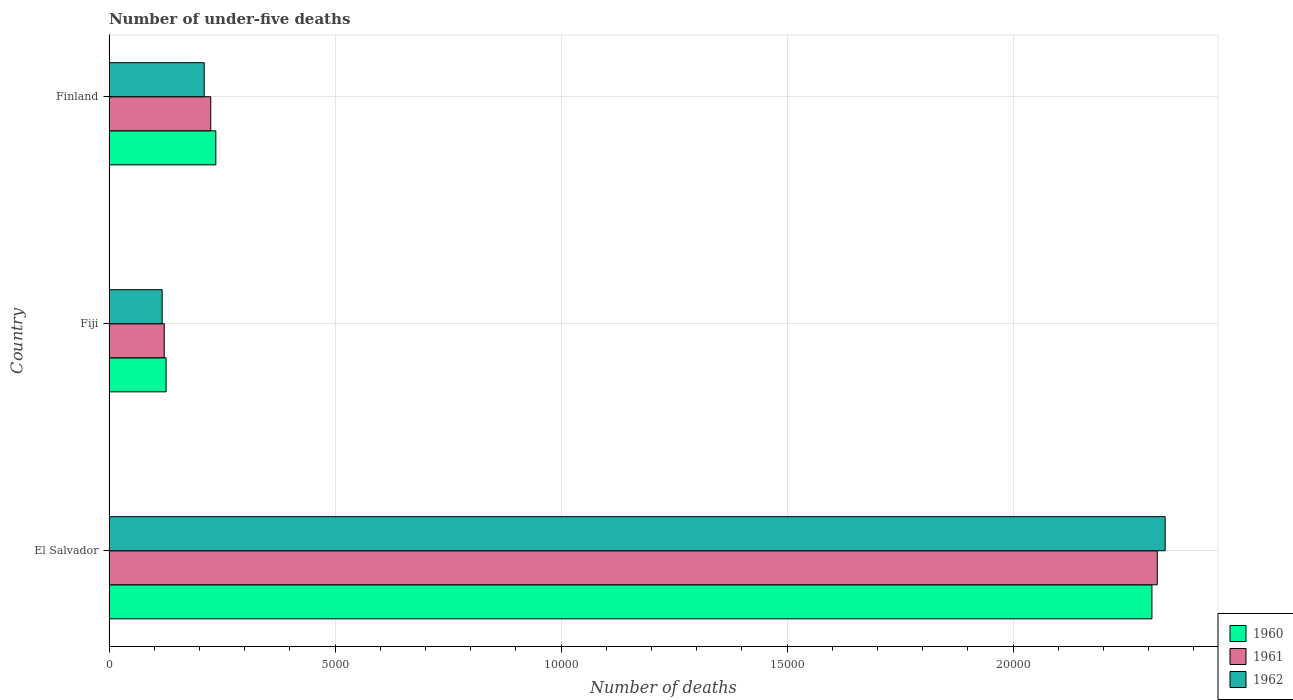How many groups of bars are there?
Provide a succinct answer. 3. Are the number of bars per tick equal to the number of legend labels?
Give a very brief answer. Yes. What is the label of the 2nd group of bars from the top?
Your answer should be very brief. Fiji. In how many cases, is the number of bars for a given country not equal to the number of legend labels?
Give a very brief answer. 0. What is the number of under-five deaths in 1961 in Fiji?
Offer a very short reply. 1222. Across all countries, what is the maximum number of under-five deaths in 1961?
Ensure brevity in your answer.  2.32e+04. Across all countries, what is the minimum number of under-five deaths in 1960?
Your answer should be very brief. 1263. In which country was the number of under-five deaths in 1962 maximum?
Keep it short and to the point. El Salvador. In which country was the number of under-five deaths in 1961 minimum?
Your response must be concise. Fiji. What is the total number of under-five deaths in 1960 in the graph?
Make the answer very short. 2.67e+04. What is the difference between the number of under-five deaths in 1962 in Fiji and that in Finland?
Provide a succinct answer. -930. What is the difference between the number of under-five deaths in 1960 in El Salvador and the number of under-five deaths in 1962 in Finland?
Provide a short and direct response. 2.10e+04. What is the average number of under-five deaths in 1961 per country?
Provide a succinct answer. 8888. What is the ratio of the number of under-five deaths in 1962 in El Salvador to that in Fiji?
Offer a terse response. 19.87. Is the difference between the number of under-five deaths in 1960 in El Salvador and Finland greater than the difference between the number of under-five deaths in 1961 in El Salvador and Finland?
Offer a very short reply. No. What is the difference between the highest and the second highest number of under-five deaths in 1962?
Give a very brief answer. 2.13e+04. What is the difference between the highest and the lowest number of under-five deaths in 1960?
Provide a succinct answer. 2.18e+04. Is the sum of the number of under-five deaths in 1962 in Fiji and Finland greater than the maximum number of under-five deaths in 1960 across all countries?
Offer a very short reply. No. How many bars are there?
Your answer should be compact. 9. Are all the bars in the graph horizontal?
Your answer should be compact. Yes. Does the graph contain any zero values?
Your response must be concise. No. Does the graph contain grids?
Offer a very short reply. Yes. Where does the legend appear in the graph?
Your response must be concise. Bottom right. How many legend labels are there?
Ensure brevity in your answer.  3. What is the title of the graph?
Your answer should be very brief. Number of under-five deaths. What is the label or title of the X-axis?
Provide a succinct answer. Number of deaths. What is the Number of deaths in 1960 in El Salvador?
Make the answer very short. 2.31e+04. What is the Number of deaths in 1961 in El Salvador?
Provide a short and direct response. 2.32e+04. What is the Number of deaths in 1962 in El Salvador?
Offer a terse response. 2.34e+04. What is the Number of deaths in 1960 in Fiji?
Offer a terse response. 1263. What is the Number of deaths in 1961 in Fiji?
Provide a short and direct response. 1222. What is the Number of deaths of 1962 in Fiji?
Keep it short and to the point. 1176. What is the Number of deaths in 1960 in Finland?
Keep it short and to the point. 2363. What is the Number of deaths of 1961 in Finland?
Your response must be concise. 2251. What is the Number of deaths of 1962 in Finland?
Your answer should be very brief. 2106. Across all countries, what is the maximum Number of deaths of 1960?
Provide a short and direct response. 2.31e+04. Across all countries, what is the maximum Number of deaths of 1961?
Ensure brevity in your answer.  2.32e+04. Across all countries, what is the maximum Number of deaths in 1962?
Your answer should be compact. 2.34e+04. Across all countries, what is the minimum Number of deaths of 1960?
Offer a very short reply. 1263. Across all countries, what is the minimum Number of deaths in 1961?
Your answer should be very brief. 1222. Across all countries, what is the minimum Number of deaths in 1962?
Your answer should be very brief. 1176. What is the total Number of deaths in 1960 in the graph?
Your answer should be very brief. 2.67e+04. What is the total Number of deaths of 1961 in the graph?
Provide a succinct answer. 2.67e+04. What is the total Number of deaths in 1962 in the graph?
Offer a very short reply. 2.66e+04. What is the difference between the Number of deaths in 1960 in El Salvador and that in Fiji?
Offer a terse response. 2.18e+04. What is the difference between the Number of deaths in 1961 in El Salvador and that in Fiji?
Ensure brevity in your answer.  2.20e+04. What is the difference between the Number of deaths in 1962 in El Salvador and that in Fiji?
Provide a succinct answer. 2.22e+04. What is the difference between the Number of deaths in 1960 in El Salvador and that in Finland?
Your response must be concise. 2.07e+04. What is the difference between the Number of deaths in 1961 in El Salvador and that in Finland?
Give a very brief answer. 2.09e+04. What is the difference between the Number of deaths in 1962 in El Salvador and that in Finland?
Offer a terse response. 2.13e+04. What is the difference between the Number of deaths of 1960 in Fiji and that in Finland?
Provide a short and direct response. -1100. What is the difference between the Number of deaths in 1961 in Fiji and that in Finland?
Your response must be concise. -1029. What is the difference between the Number of deaths of 1962 in Fiji and that in Finland?
Provide a succinct answer. -930. What is the difference between the Number of deaths of 1960 in El Salvador and the Number of deaths of 1961 in Fiji?
Your answer should be compact. 2.19e+04. What is the difference between the Number of deaths of 1960 in El Salvador and the Number of deaths of 1962 in Fiji?
Make the answer very short. 2.19e+04. What is the difference between the Number of deaths in 1961 in El Salvador and the Number of deaths in 1962 in Fiji?
Your answer should be compact. 2.20e+04. What is the difference between the Number of deaths in 1960 in El Salvador and the Number of deaths in 1961 in Finland?
Give a very brief answer. 2.08e+04. What is the difference between the Number of deaths of 1960 in El Salvador and the Number of deaths of 1962 in Finland?
Ensure brevity in your answer.  2.10e+04. What is the difference between the Number of deaths of 1961 in El Salvador and the Number of deaths of 1962 in Finland?
Make the answer very short. 2.11e+04. What is the difference between the Number of deaths of 1960 in Fiji and the Number of deaths of 1961 in Finland?
Keep it short and to the point. -988. What is the difference between the Number of deaths of 1960 in Fiji and the Number of deaths of 1962 in Finland?
Your answer should be very brief. -843. What is the difference between the Number of deaths of 1961 in Fiji and the Number of deaths of 1962 in Finland?
Ensure brevity in your answer.  -884. What is the average Number of deaths of 1960 per country?
Your answer should be compact. 8899.67. What is the average Number of deaths in 1961 per country?
Provide a succinct answer. 8888. What is the average Number of deaths of 1962 per country?
Ensure brevity in your answer.  8882.67. What is the difference between the Number of deaths in 1960 and Number of deaths in 1961 in El Salvador?
Your response must be concise. -118. What is the difference between the Number of deaths of 1960 and Number of deaths of 1962 in El Salvador?
Offer a terse response. -293. What is the difference between the Number of deaths of 1961 and Number of deaths of 1962 in El Salvador?
Give a very brief answer. -175. What is the difference between the Number of deaths of 1960 and Number of deaths of 1962 in Fiji?
Offer a very short reply. 87. What is the difference between the Number of deaths of 1961 and Number of deaths of 1962 in Fiji?
Your answer should be compact. 46. What is the difference between the Number of deaths in 1960 and Number of deaths in 1961 in Finland?
Keep it short and to the point. 112. What is the difference between the Number of deaths of 1960 and Number of deaths of 1962 in Finland?
Give a very brief answer. 257. What is the difference between the Number of deaths of 1961 and Number of deaths of 1962 in Finland?
Give a very brief answer. 145. What is the ratio of the Number of deaths in 1960 in El Salvador to that in Fiji?
Make the answer very short. 18.27. What is the ratio of the Number of deaths in 1961 in El Salvador to that in Fiji?
Offer a very short reply. 18.98. What is the ratio of the Number of deaths in 1962 in El Salvador to that in Fiji?
Provide a short and direct response. 19.87. What is the ratio of the Number of deaths of 1960 in El Salvador to that in Finland?
Provide a succinct answer. 9.76. What is the ratio of the Number of deaths in 1961 in El Salvador to that in Finland?
Offer a terse response. 10.3. What is the ratio of the Number of deaths of 1962 in El Salvador to that in Finland?
Your answer should be very brief. 11.1. What is the ratio of the Number of deaths in 1960 in Fiji to that in Finland?
Provide a succinct answer. 0.53. What is the ratio of the Number of deaths of 1961 in Fiji to that in Finland?
Make the answer very short. 0.54. What is the ratio of the Number of deaths in 1962 in Fiji to that in Finland?
Keep it short and to the point. 0.56. What is the difference between the highest and the second highest Number of deaths of 1960?
Offer a terse response. 2.07e+04. What is the difference between the highest and the second highest Number of deaths of 1961?
Offer a terse response. 2.09e+04. What is the difference between the highest and the second highest Number of deaths in 1962?
Give a very brief answer. 2.13e+04. What is the difference between the highest and the lowest Number of deaths in 1960?
Ensure brevity in your answer.  2.18e+04. What is the difference between the highest and the lowest Number of deaths in 1961?
Your answer should be very brief. 2.20e+04. What is the difference between the highest and the lowest Number of deaths in 1962?
Keep it short and to the point. 2.22e+04. 